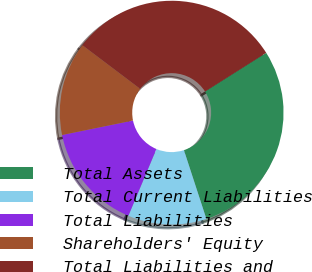Convert chart to OTSL. <chart><loc_0><loc_0><loc_500><loc_500><pie_chart><fcel>Total Assets<fcel>Total Current Liabilities<fcel>Total Liabilities<fcel>Shareholders' Equity<fcel>Total Liabilities and<nl><fcel>28.96%<fcel>11.35%<fcel>15.47%<fcel>13.5%<fcel>30.73%<nl></chart> 